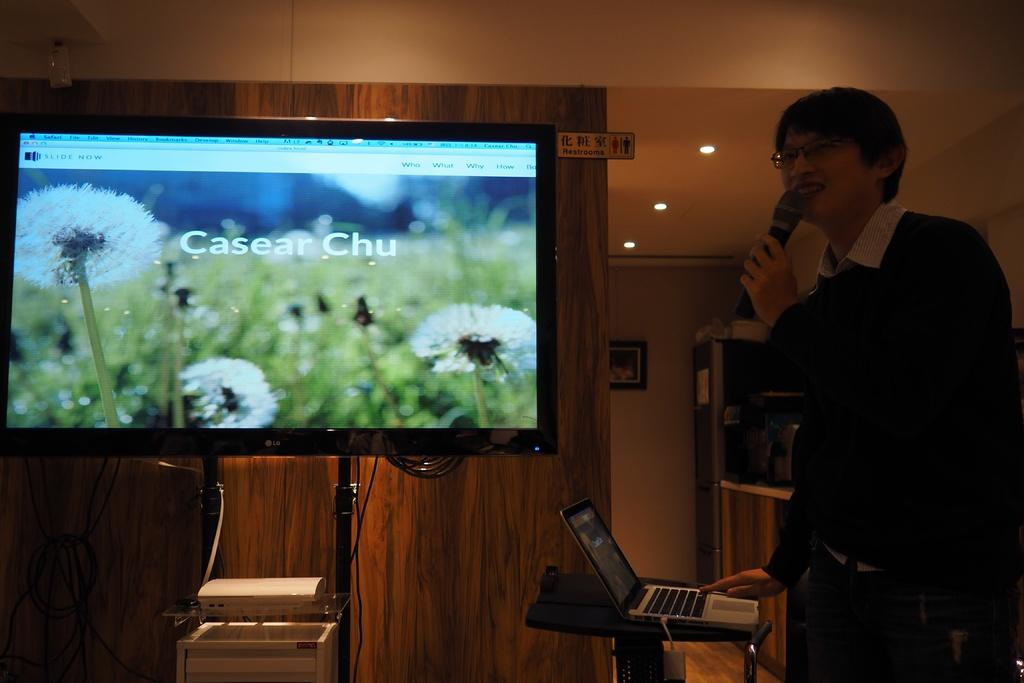<image>
Render a clear and concise summary of the photo. Caeser Chu is written on the large, flat TV screen being presented by a man with glasses. 